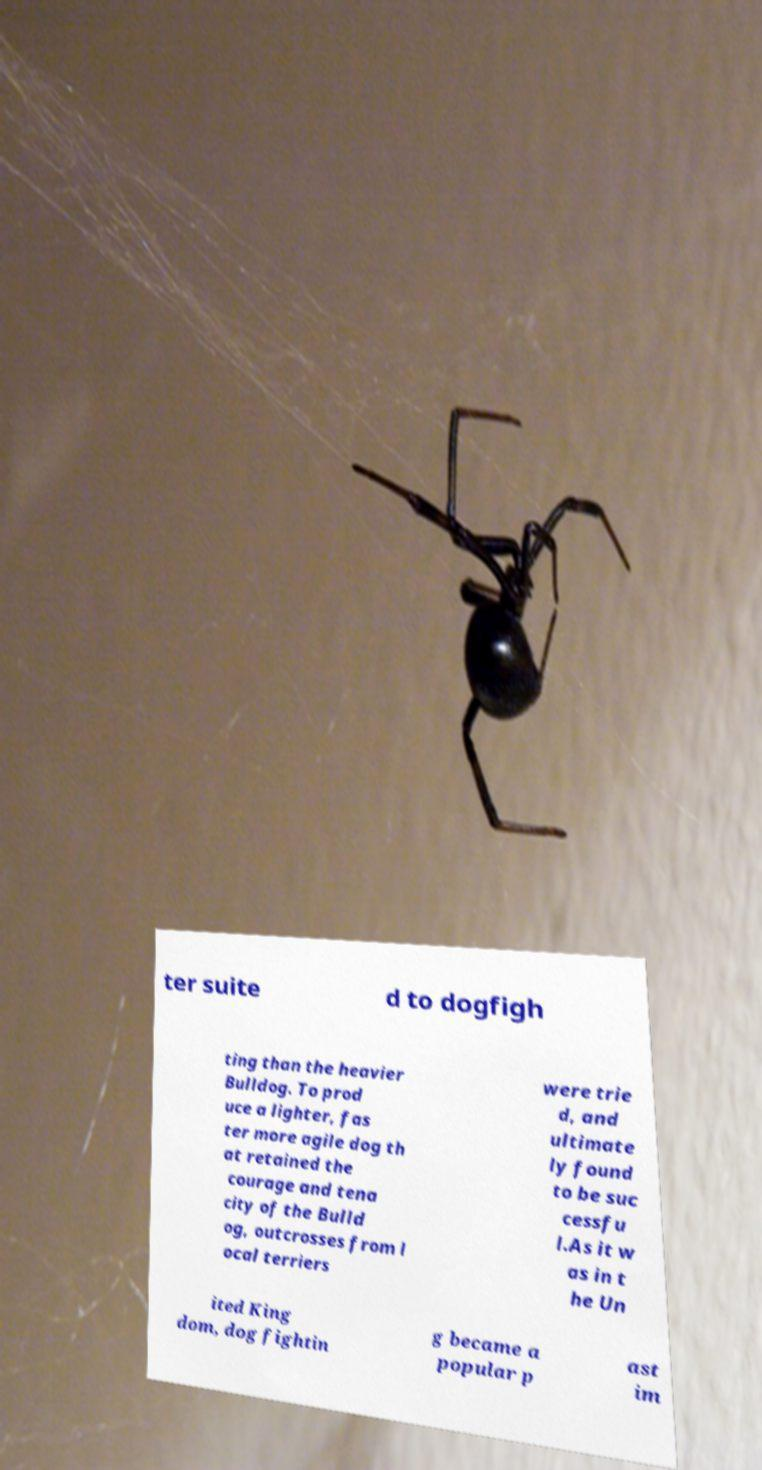Can you accurately transcribe the text from the provided image for me? ter suite d to dogfigh ting than the heavier Bulldog. To prod uce a lighter, fas ter more agile dog th at retained the courage and tena city of the Bulld og, outcrosses from l ocal terriers were trie d, and ultimate ly found to be suc cessfu l.As it w as in t he Un ited King dom, dog fightin g became a popular p ast im 